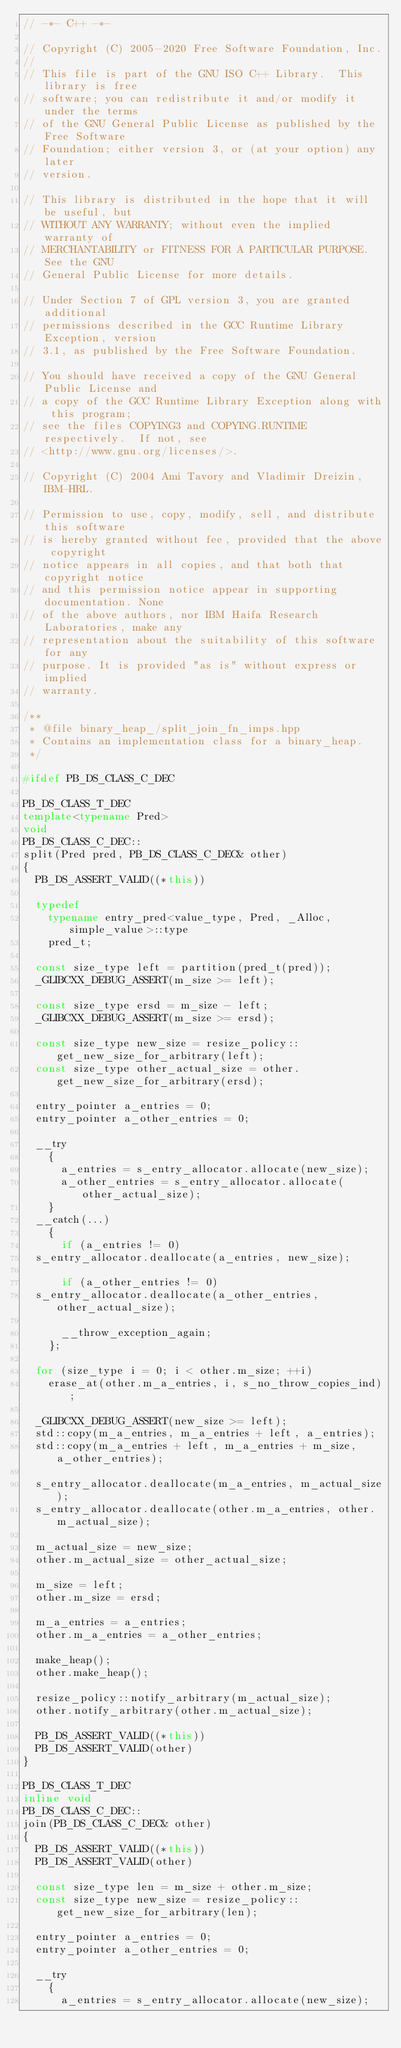Convert code to text. <code><loc_0><loc_0><loc_500><loc_500><_C++_>// -*- C++ -*-

// Copyright (C) 2005-2020 Free Software Foundation, Inc.
//
// This file is part of the GNU ISO C++ Library.  This library is free
// software; you can redistribute it and/or modify it under the terms
// of the GNU General Public License as published by the Free Software
// Foundation; either version 3, or (at your option) any later
// version.

// This library is distributed in the hope that it will be useful, but
// WITHOUT ANY WARRANTY; without even the implied warranty of
// MERCHANTABILITY or FITNESS FOR A PARTICULAR PURPOSE.  See the GNU
// General Public License for more details.

// Under Section 7 of GPL version 3, you are granted additional
// permissions described in the GCC Runtime Library Exception, version
// 3.1, as published by the Free Software Foundation.

// You should have received a copy of the GNU General Public License and
// a copy of the GCC Runtime Library Exception along with this program;
// see the files COPYING3 and COPYING.RUNTIME respectively.  If not, see
// <http://www.gnu.org/licenses/>.

// Copyright (C) 2004 Ami Tavory and Vladimir Dreizin, IBM-HRL.

// Permission to use, copy, modify, sell, and distribute this software
// is hereby granted without fee, provided that the above copyright
// notice appears in all copies, and that both that copyright notice
// and this permission notice appear in supporting documentation. None
// of the above authors, nor IBM Haifa Research Laboratories, make any
// representation about the suitability of this software for any
// purpose. It is provided "as is" without express or implied
// warranty.

/**
 * @file binary_heap_/split_join_fn_imps.hpp
 * Contains an implementation class for a binary_heap.
 */

#ifdef PB_DS_CLASS_C_DEC

PB_DS_CLASS_T_DEC
template<typename Pred>
void
PB_DS_CLASS_C_DEC::
split(Pred pred, PB_DS_CLASS_C_DEC& other)
{
  PB_DS_ASSERT_VALID((*this))

  typedef
    typename entry_pred<value_type, Pred, _Alloc, simple_value>::type
    pred_t;

  const size_type left = partition(pred_t(pred));
  _GLIBCXX_DEBUG_ASSERT(m_size >= left);

  const size_type ersd = m_size - left;
  _GLIBCXX_DEBUG_ASSERT(m_size >= ersd);

  const size_type new_size = resize_policy::get_new_size_for_arbitrary(left);
  const size_type other_actual_size = other.get_new_size_for_arbitrary(ersd);

  entry_pointer a_entries = 0;
  entry_pointer a_other_entries = 0;

  __try
    {
      a_entries = s_entry_allocator.allocate(new_size);
      a_other_entries = s_entry_allocator.allocate(other_actual_size);
    }
  __catch(...)
    {
      if (a_entries != 0)
	s_entry_allocator.deallocate(a_entries, new_size);

      if (a_other_entries != 0)
	s_entry_allocator.deallocate(a_other_entries, other_actual_size);

      __throw_exception_again;
    };

  for (size_type i = 0; i < other.m_size; ++i)
    erase_at(other.m_a_entries, i, s_no_throw_copies_ind);

  _GLIBCXX_DEBUG_ASSERT(new_size >= left);
  std::copy(m_a_entries, m_a_entries + left, a_entries);
  std::copy(m_a_entries + left, m_a_entries + m_size, a_other_entries);

  s_entry_allocator.deallocate(m_a_entries, m_actual_size);
  s_entry_allocator.deallocate(other.m_a_entries, other.m_actual_size);

  m_actual_size = new_size;
  other.m_actual_size = other_actual_size;

  m_size = left;
  other.m_size = ersd;

  m_a_entries = a_entries;
  other.m_a_entries = a_other_entries;

  make_heap();
  other.make_heap();

  resize_policy::notify_arbitrary(m_actual_size);
  other.notify_arbitrary(other.m_actual_size);

  PB_DS_ASSERT_VALID((*this))
  PB_DS_ASSERT_VALID(other)
}

PB_DS_CLASS_T_DEC
inline void
PB_DS_CLASS_C_DEC::
join(PB_DS_CLASS_C_DEC& other)
{
  PB_DS_ASSERT_VALID((*this))
  PB_DS_ASSERT_VALID(other)

  const size_type len = m_size + other.m_size;
  const size_type new_size = resize_policy::get_new_size_for_arbitrary(len);

  entry_pointer a_entries = 0;
  entry_pointer a_other_entries = 0;

  __try
    {
      a_entries = s_entry_allocator.allocate(new_size);</code> 